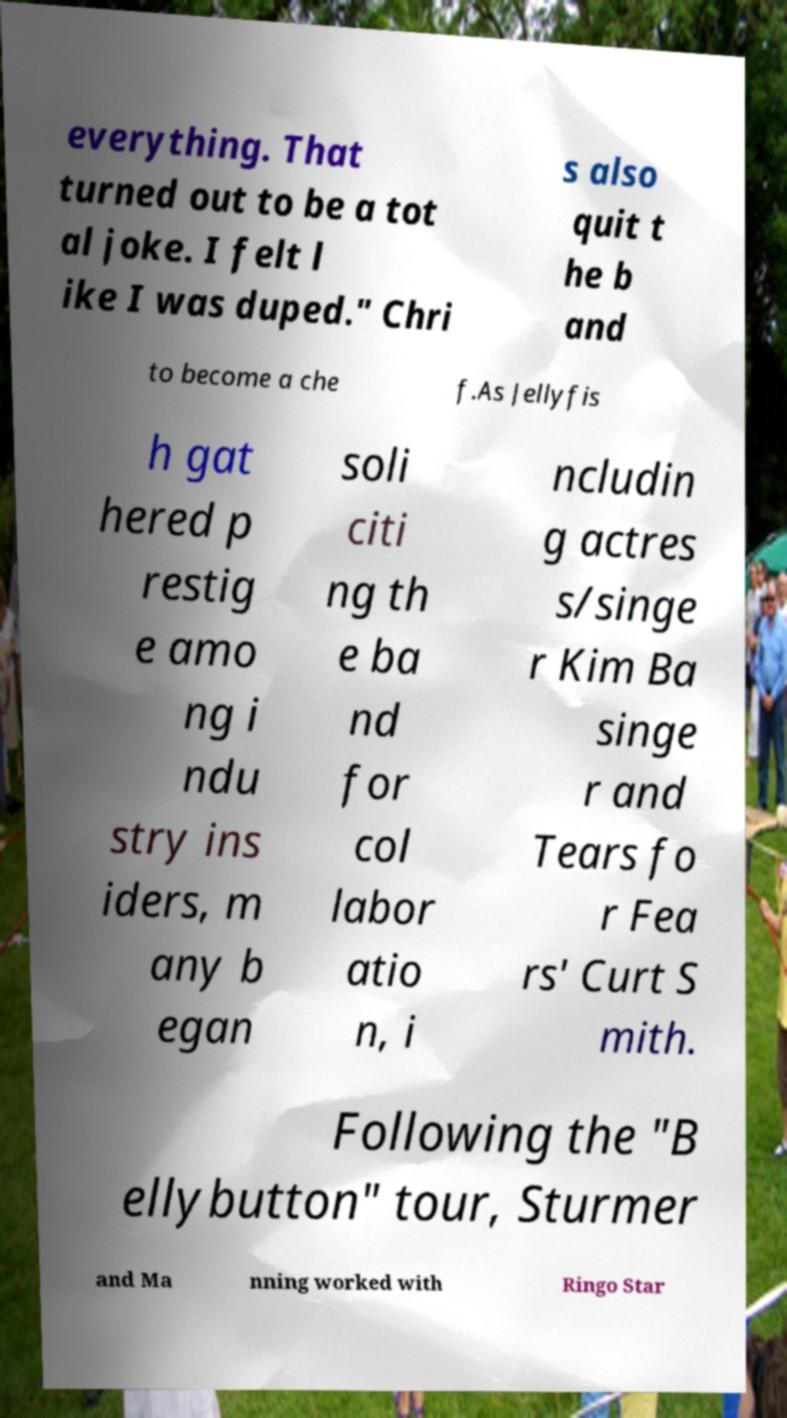Can you accurately transcribe the text from the provided image for me? everything. That turned out to be a tot al joke. I felt l ike I was duped." Chri s also quit t he b and to become a che f.As Jellyfis h gat hered p restig e amo ng i ndu stry ins iders, m any b egan soli citi ng th e ba nd for col labor atio n, i ncludin g actres s/singe r Kim Ba singe r and Tears fo r Fea rs' Curt S mith. Following the "B ellybutton" tour, Sturmer and Ma nning worked with Ringo Star 